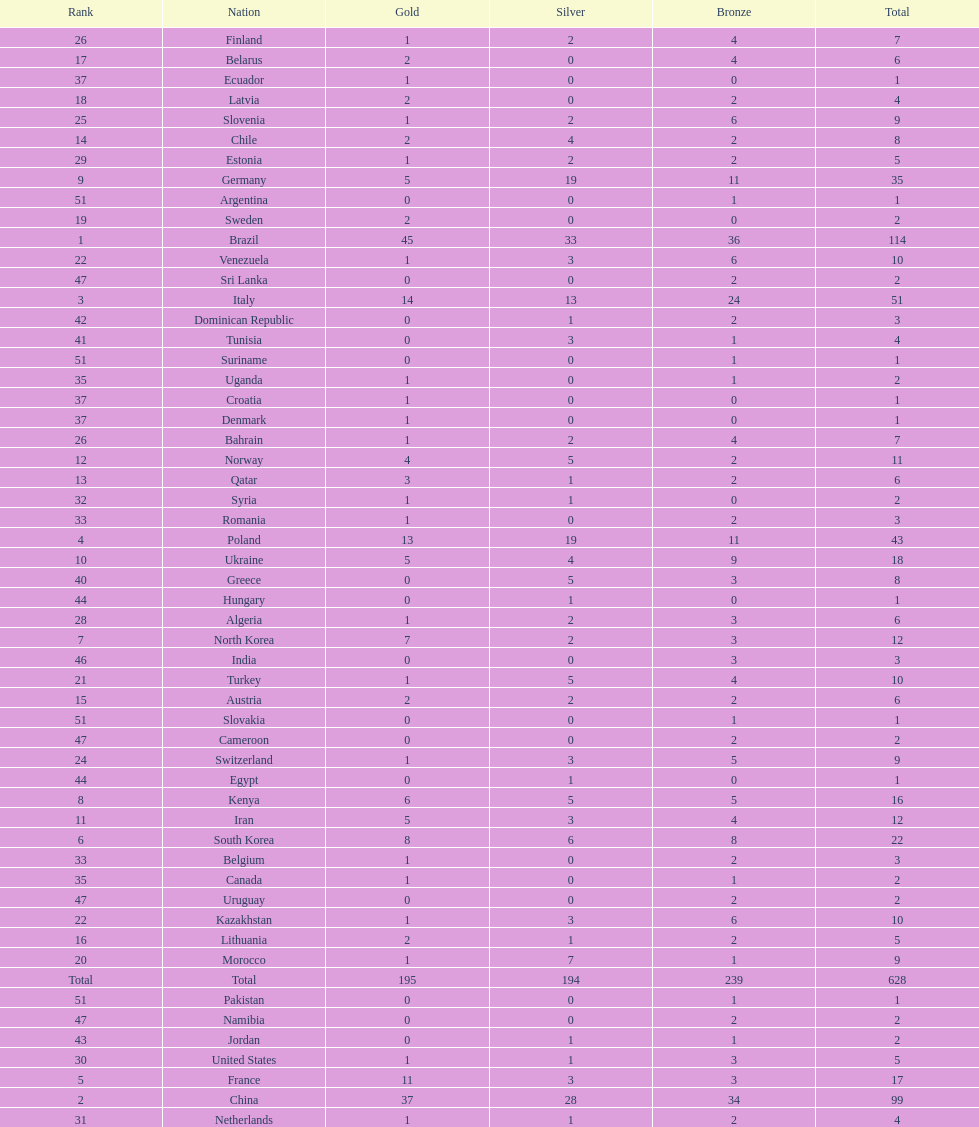South korea has how many more medals that north korea? 10. 